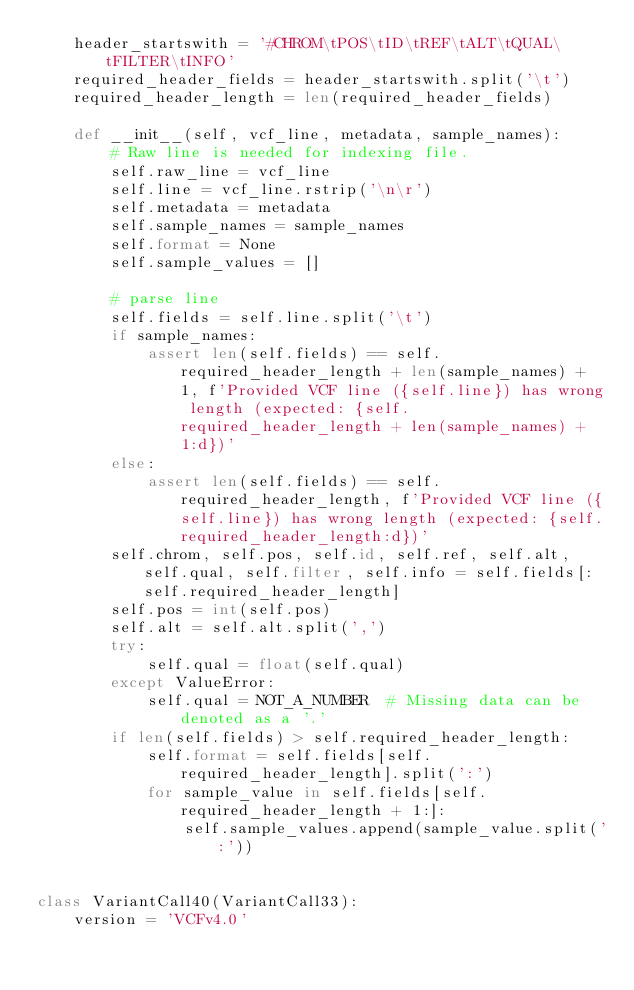<code> <loc_0><loc_0><loc_500><loc_500><_Python_>    header_startswith = '#CHROM\tPOS\tID\tREF\tALT\tQUAL\tFILTER\tINFO'
    required_header_fields = header_startswith.split('\t')
    required_header_length = len(required_header_fields)

    def __init__(self, vcf_line, metadata, sample_names):
        # Raw line is needed for indexing file.
        self.raw_line = vcf_line
        self.line = vcf_line.rstrip('\n\r')
        self.metadata = metadata
        self.sample_names = sample_names
        self.format = None
        self.sample_values = []

        # parse line
        self.fields = self.line.split('\t')
        if sample_names:
            assert len(self.fields) == self.required_header_length + len(sample_names) + 1, f'Provided VCF line ({self.line}) has wrong length (expected: {self.required_header_length + len(sample_names) + 1:d})'
        else:
            assert len(self.fields) == self.required_header_length, f'Provided VCF line ({self.line}) has wrong length (expected: {self.required_header_length:d})'
        self.chrom, self.pos, self.id, self.ref, self.alt, self.qual, self.filter, self.info = self.fields[:self.required_header_length]
        self.pos = int(self.pos)
        self.alt = self.alt.split(',')
        try:
            self.qual = float(self.qual)
        except ValueError:
            self.qual = NOT_A_NUMBER  # Missing data can be denoted as a '.'
        if len(self.fields) > self.required_header_length:
            self.format = self.fields[self.required_header_length].split(':')
            for sample_value in self.fields[self.required_header_length + 1:]:
                self.sample_values.append(sample_value.split(':'))


class VariantCall40(VariantCall33):
    version = 'VCFv4.0'
</code> 